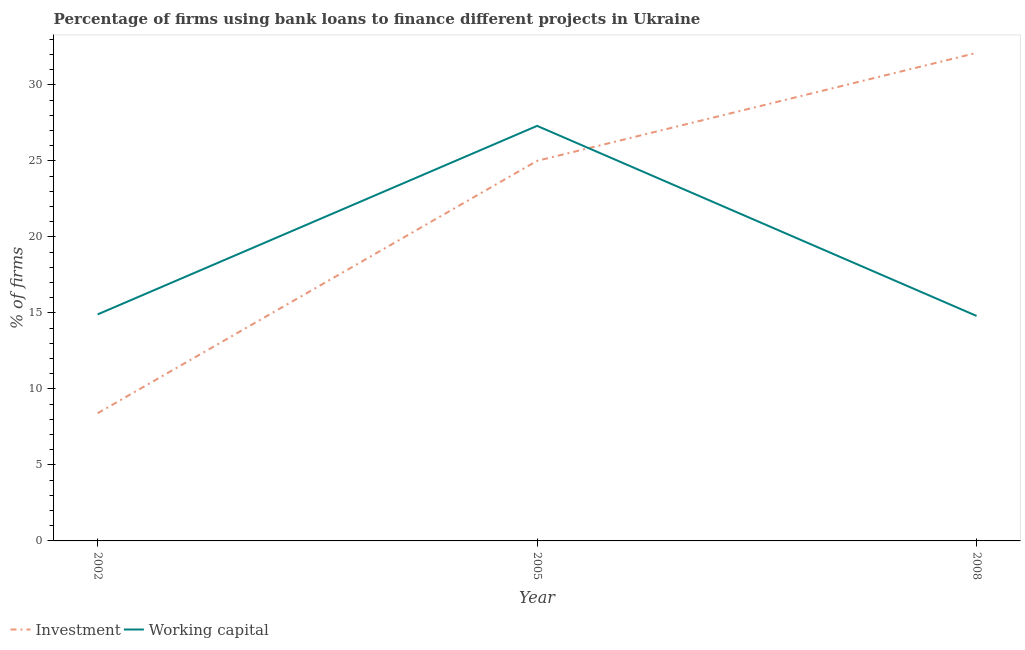Does the line corresponding to percentage of firms using banks to finance working capital intersect with the line corresponding to percentage of firms using banks to finance investment?
Your response must be concise. Yes. Is the number of lines equal to the number of legend labels?
Your answer should be very brief. Yes. What is the percentage of firms using banks to finance investment in 2005?
Make the answer very short. 25. Across all years, what is the maximum percentage of firms using banks to finance working capital?
Offer a very short reply. 27.3. What is the difference between the percentage of firms using banks to finance investment in 2005 and the percentage of firms using banks to finance working capital in 2008?
Your answer should be compact. 10.2. What is the average percentage of firms using banks to finance working capital per year?
Your answer should be very brief. 19. In the year 2005, what is the difference between the percentage of firms using banks to finance investment and percentage of firms using banks to finance working capital?
Give a very brief answer. -2.3. What is the ratio of the percentage of firms using banks to finance working capital in 2002 to that in 2005?
Provide a short and direct response. 0.55. Is the difference between the percentage of firms using banks to finance working capital in 2002 and 2005 greater than the difference between the percentage of firms using banks to finance investment in 2002 and 2005?
Your answer should be very brief. Yes. What is the difference between the highest and the second highest percentage of firms using banks to finance working capital?
Your response must be concise. 12.4. Is the sum of the percentage of firms using banks to finance working capital in 2005 and 2008 greater than the maximum percentage of firms using banks to finance investment across all years?
Offer a very short reply. Yes. Is the percentage of firms using banks to finance investment strictly greater than the percentage of firms using banks to finance working capital over the years?
Your response must be concise. No. How many lines are there?
Offer a very short reply. 2. What is the difference between two consecutive major ticks on the Y-axis?
Give a very brief answer. 5. Does the graph contain any zero values?
Provide a short and direct response. No. Where does the legend appear in the graph?
Your answer should be very brief. Bottom left. How many legend labels are there?
Provide a short and direct response. 2. How are the legend labels stacked?
Offer a very short reply. Horizontal. What is the title of the graph?
Your response must be concise. Percentage of firms using bank loans to finance different projects in Ukraine. What is the label or title of the Y-axis?
Your response must be concise. % of firms. What is the % of firms of Investment in 2002?
Your answer should be compact. 8.4. What is the % of firms of Working capital in 2005?
Make the answer very short. 27.3. What is the % of firms of Investment in 2008?
Your answer should be compact. 32.1. Across all years, what is the maximum % of firms in Investment?
Provide a succinct answer. 32.1. Across all years, what is the maximum % of firms of Working capital?
Ensure brevity in your answer.  27.3. Across all years, what is the minimum % of firms in Investment?
Offer a very short reply. 8.4. What is the total % of firms in Investment in the graph?
Your response must be concise. 65.5. What is the total % of firms of Working capital in the graph?
Provide a succinct answer. 57. What is the difference between the % of firms in Investment in 2002 and that in 2005?
Your response must be concise. -16.6. What is the difference between the % of firms of Investment in 2002 and that in 2008?
Your answer should be very brief. -23.7. What is the difference between the % of firms of Investment in 2005 and that in 2008?
Make the answer very short. -7.1. What is the difference between the % of firms in Working capital in 2005 and that in 2008?
Ensure brevity in your answer.  12.5. What is the difference between the % of firms in Investment in 2002 and the % of firms in Working capital in 2005?
Ensure brevity in your answer.  -18.9. What is the difference between the % of firms of Investment in 2002 and the % of firms of Working capital in 2008?
Provide a short and direct response. -6.4. What is the difference between the % of firms of Investment in 2005 and the % of firms of Working capital in 2008?
Provide a succinct answer. 10.2. What is the average % of firms of Investment per year?
Keep it short and to the point. 21.83. In the year 2005, what is the difference between the % of firms of Investment and % of firms of Working capital?
Provide a short and direct response. -2.3. What is the ratio of the % of firms in Investment in 2002 to that in 2005?
Your answer should be very brief. 0.34. What is the ratio of the % of firms in Working capital in 2002 to that in 2005?
Provide a succinct answer. 0.55. What is the ratio of the % of firms in Investment in 2002 to that in 2008?
Give a very brief answer. 0.26. What is the ratio of the % of firms in Working capital in 2002 to that in 2008?
Provide a short and direct response. 1.01. What is the ratio of the % of firms in Investment in 2005 to that in 2008?
Make the answer very short. 0.78. What is the ratio of the % of firms of Working capital in 2005 to that in 2008?
Offer a very short reply. 1.84. What is the difference between the highest and the second highest % of firms in Working capital?
Ensure brevity in your answer.  12.4. What is the difference between the highest and the lowest % of firms in Investment?
Keep it short and to the point. 23.7. What is the difference between the highest and the lowest % of firms of Working capital?
Offer a terse response. 12.5. 